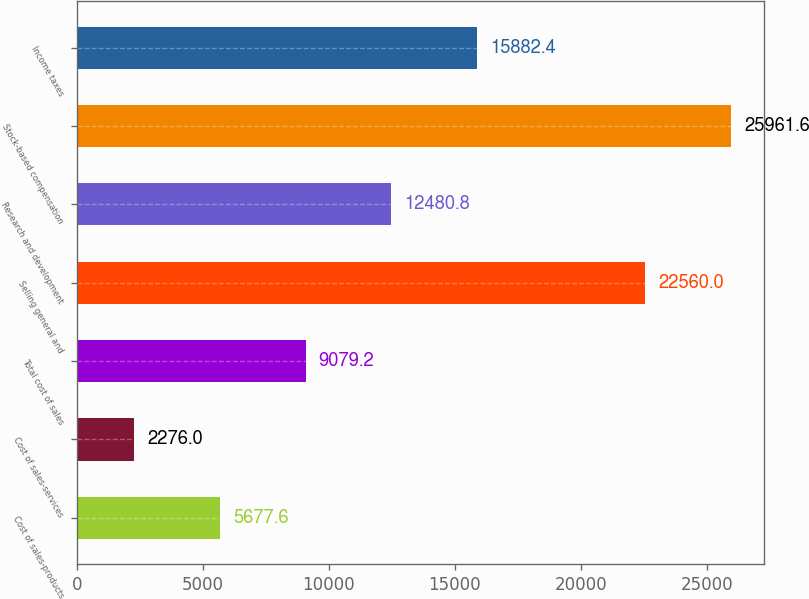Convert chart. <chart><loc_0><loc_0><loc_500><loc_500><bar_chart><fcel>Cost of sales-products<fcel>Cost of sales-services<fcel>Total cost of sales<fcel>Selling general and<fcel>Research and development<fcel>Stock-based compensation<fcel>Income taxes<nl><fcel>5677.6<fcel>2276<fcel>9079.2<fcel>22560<fcel>12480.8<fcel>25961.6<fcel>15882.4<nl></chart> 